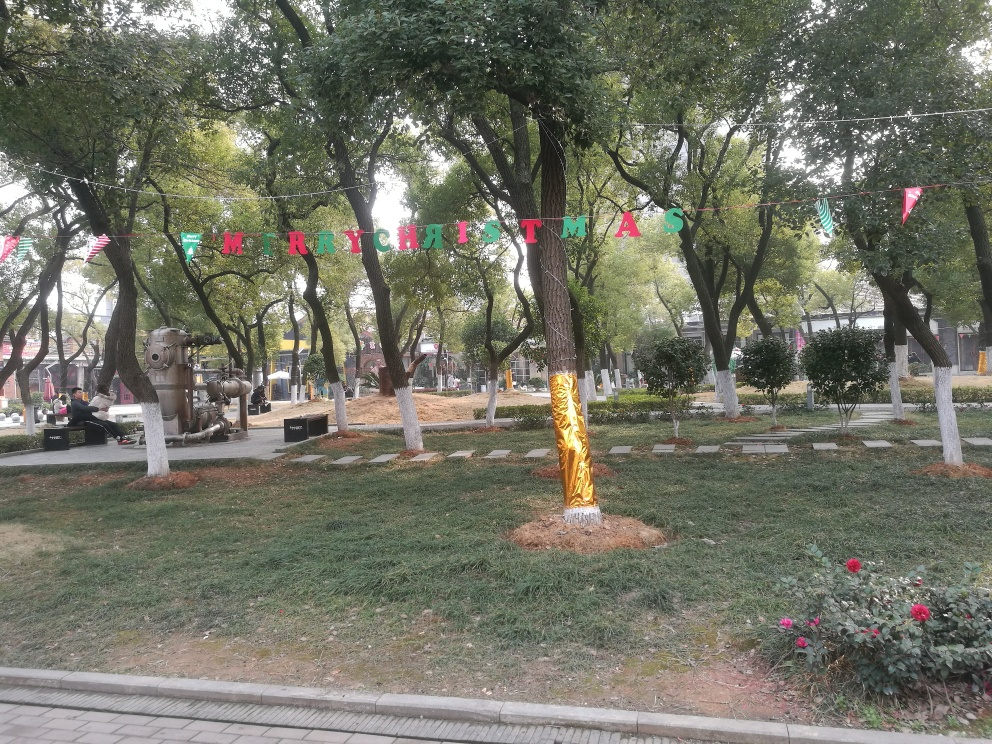What might be the purpose of the metallic structures in the park? The metallic structures appear to be artistic installations or sculptures within the park. They serve as creative elements that enhance the visual appeal and cultural attractiveness of the space, potentially inviting park-goers to engage with the area in a more thoughtful or contemplative manner. What kind of activities do you think visitors engage in at this park? Visitors to this park likely engage in casual strolls, relaxation on the benches, and enjoying the greenery. The presence of walking paths suggests people might come here for exercise like jogging. The playful Christmas decorations also indicate it could be a space for seasonal celebrations and gatherings. 